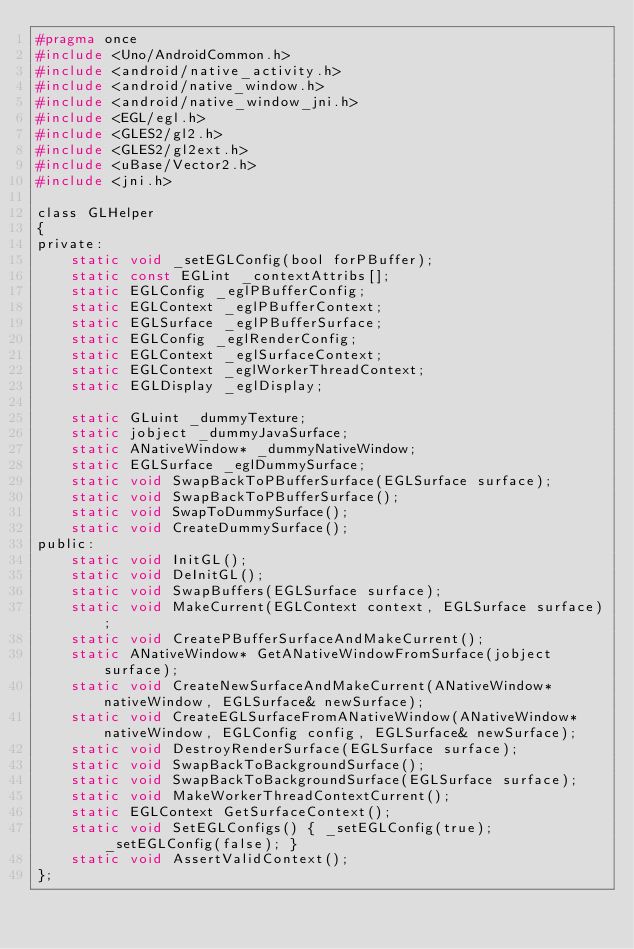<code> <loc_0><loc_0><loc_500><loc_500><_C_>#pragma once
#include <Uno/AndroidCommon.h>
#include <android/native_activity.h>
#include <android/native_window.h>
#include <android/native_window_jni.h>
#include <EGL/egl.h>
#include <GLES2/gl2.h>
#include <GLES2/gl2ext.h>
#include <uBase/Vector2.h>
#include <jni.h>

class GLHelper
{
private:
    static void _setEGLConfig(bool forPBuffer);
    static const EGLint _contextAttribs[];
    static EGLConfig _eglPBufferConfig;
    static EGLContext _eglPBufferContext;
    static EGLSurface _eglPBufferSurface;
    static EGLConfig _eglRenderConfig;
    static EGLContext _eglSurfaceContext;
    static EGLContext _eglWorkerThreadContext;
    static EGLDisplay _eglDisplay;

    static GLuint _dummyTexture;
    static jobject _dummyJavaSurface;
    static ANativeWindow* _dummyNativeWindow;
    static EGLSurface _eglDummySurface;
    static void SwapBackToPBufferSurface(EGLSurface surface);
    static void SwapBackToPBufferSurface();
    static void SwapToDummySurface();
    static void CreateDummySurface();
public:
    static void InitGL();
    static void DeInitGL();
    static void SwapBuffers(EGLSurface surface);
    static void MakeCurrent(EGLContext context, EGLSurface surface);
    static void CreatePBufferSurfaceAndMakeCurrent();
    static ANativeWindow* GetANativeWindowFromSurface(jobject surface);
    static void CreateNewSurfaceAndMakeCurrent(ANativeWindow* nativeWindow, EGLSurface& newSurface);
    static void CreateEGLSurfaceFromANativeWindow(ANativeWindow* nativeWindow, EGLConfig config, EGLSurface& newSurface);
    static void DestroyRenderSurface(EGLSurface surface);
    static void SwapBackToBackgroundSurface();
    static void SwapBackToBackgroundSurface(EGLSurface surface);
    static void MakeWorkerThreadContextCurrent();
    static EGLContext GetSurfaceContext();
    static void SetEGLConfigs() { _setEGLConfig(true); _setEGLConfig(false); }
    static void AssertValidContext();
};
</code> 